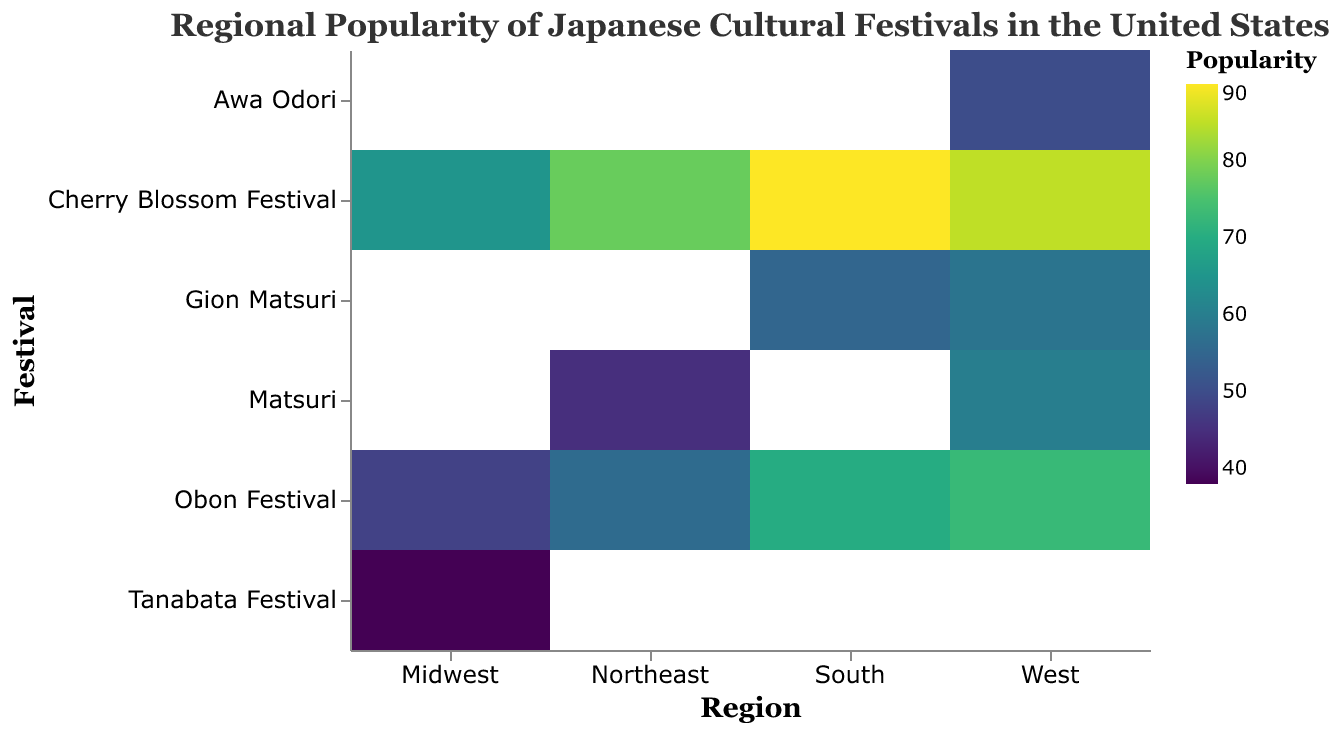What is the most popular festival in the Northeast region? The heatmap shows that the Cherry Blossom Festival is represented with the darkest shade in the Northeast region, indicating the highest popularity.
Answer: Cherry Blossom Festival Which region has the highest popularity for the Obon Festival? By comparing the color intensity of the Obon Festival across all regions, the West region has the darkest shade, which suggests the highest popularity.
Answer: West How many festivals are presented in the West region? The y-axis lists all festivals, and observing the entries under the West column reveals five different festivals.
Answer: Five What is the least popular festival in the Midwest region? The heatmap shows lighter shades indicating lower popularity. Seeing the Midwest column, the Tanabata Festival has the lightest color shade, thus the least popularity.
Answer: Tanabata Festival List the regions in descending order of popularity for the Cherry Blossom Festival. By comparing the color intensity of the Cherry Blossom Festival across all regions, we get the following descending order: South, West, Northeast, Midwest.
Answer: South, West, Northeast, Midwest Which region has the overall highest popularity for festivals? The overall highest popularity can be estimated by observing the darkest shades of the heatmap across all regions, and the South region displays the most consistent darker shades across multiple festivals indicating the highest popularity overall.
Answer: South What is the average popularity of the Cherry Blossom Festival across all regions? Add the popularity values for the Cherry Blossom Festival from all regions (78+65+90+85) and then divide by the number of regions (4). Calculation: (78+65+90+85)/4 = 79.5
Answer: 79.5 Which festivals are equally popular in the West region? By observing the heatmap, it can be seen that there are no festivals in the West region that have exactly the same color shade, indicating differing popularity values.
Answer: None How does the popularity of Matsuri in the Northeast compare to that of the Tanabata Festival in the Midwest? The heatmap shows that Matsuri in the Northeast has a popularity of 45, while the Tanabata Festival in the Midwest has a popularity of 38. Comparing the two values shows that Matsuri in the Northeast is more popular.
Answer: Matsuri in the Northeast is more popular What is the total popularity of the Obon Festival across all regions? Sum the popularity values of the Obon Festival from all regions (56 + 48 + 70 + 73). Calculation: 56 + 48 + 70 + 73 = 247
Answer: 247 